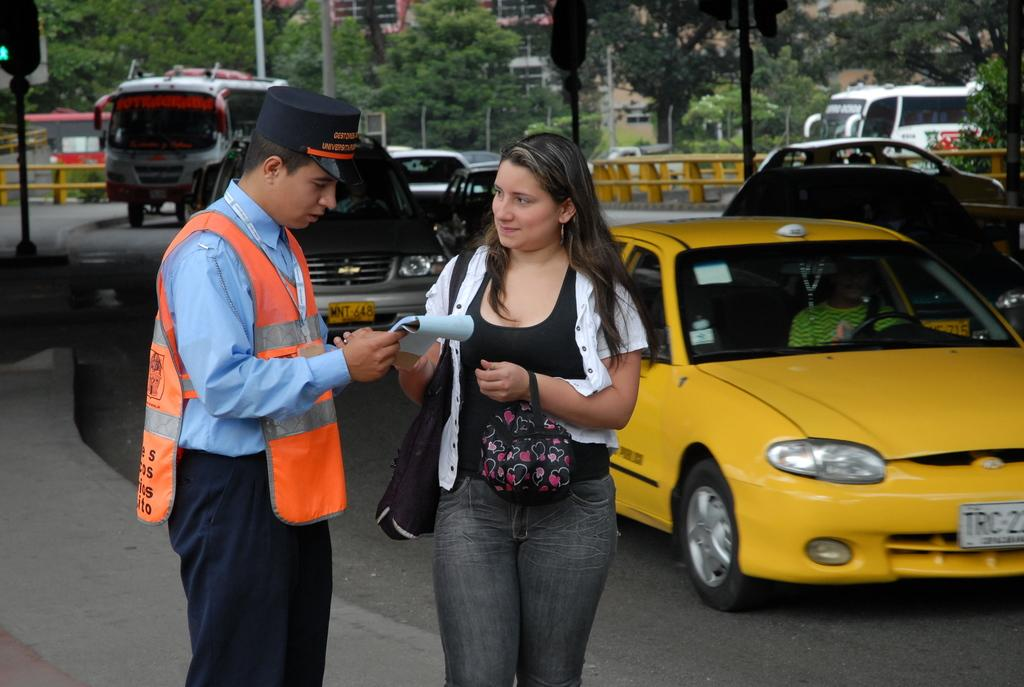<image>
Render a clear and concise summary of the photo. a yellow car that has TRC on it 